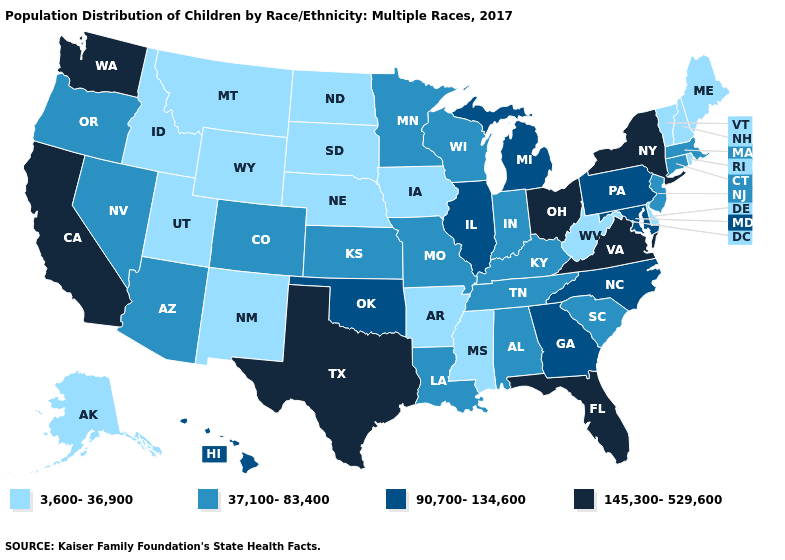Does Idaho have the highest value in the USA?
Answer briefly. No. What is the value of Hawaii?
Keep it brief. 90,700-134,600. Which states have the lowest value in the Northeast?
Write a very short answer. Maine, New Hampshire, Rhode Island, Vermont. What is the value of Mississippi?
Short answer required. 3,600-36,900. What is the highest value in the USA?
Be succinct. 145,300-529,600. What is the value of Mississippi?
Give a very brief answer. 3,600-36,900. How many symbols are there in the legend?
Answer briefly. 4. Name the states that have a value in the range 37,100-83,400?
Answer briefly. Alabama, Arizona, Colorado, Connecticut, Indiana, Kansas, Kentucky, Louisiana, Massachusetts, Minnesota, Missouri, Nevada, New Jersey, Oregon, South Carolina, Tennessee, Wisconsin. How many symbols are there in the legend?
Keep it brief. 4. What is the highest value in states that border Florida?
Keep it brief. 90,700-134,600. Does Hawaii have the lowest value in the USA?
Keep it brief. No. Does the first symbol in the legend represent the smallest category?
Short answer required. Yes. Among the states that border Kansas , which have the lowest value?
Be succinct. Nebraska. What is the value of Vermont?
Short answer required. 3,600-36,900. What is the highest value in states that border Indiana?
Give a very brief answer. 145,300-529,600. 